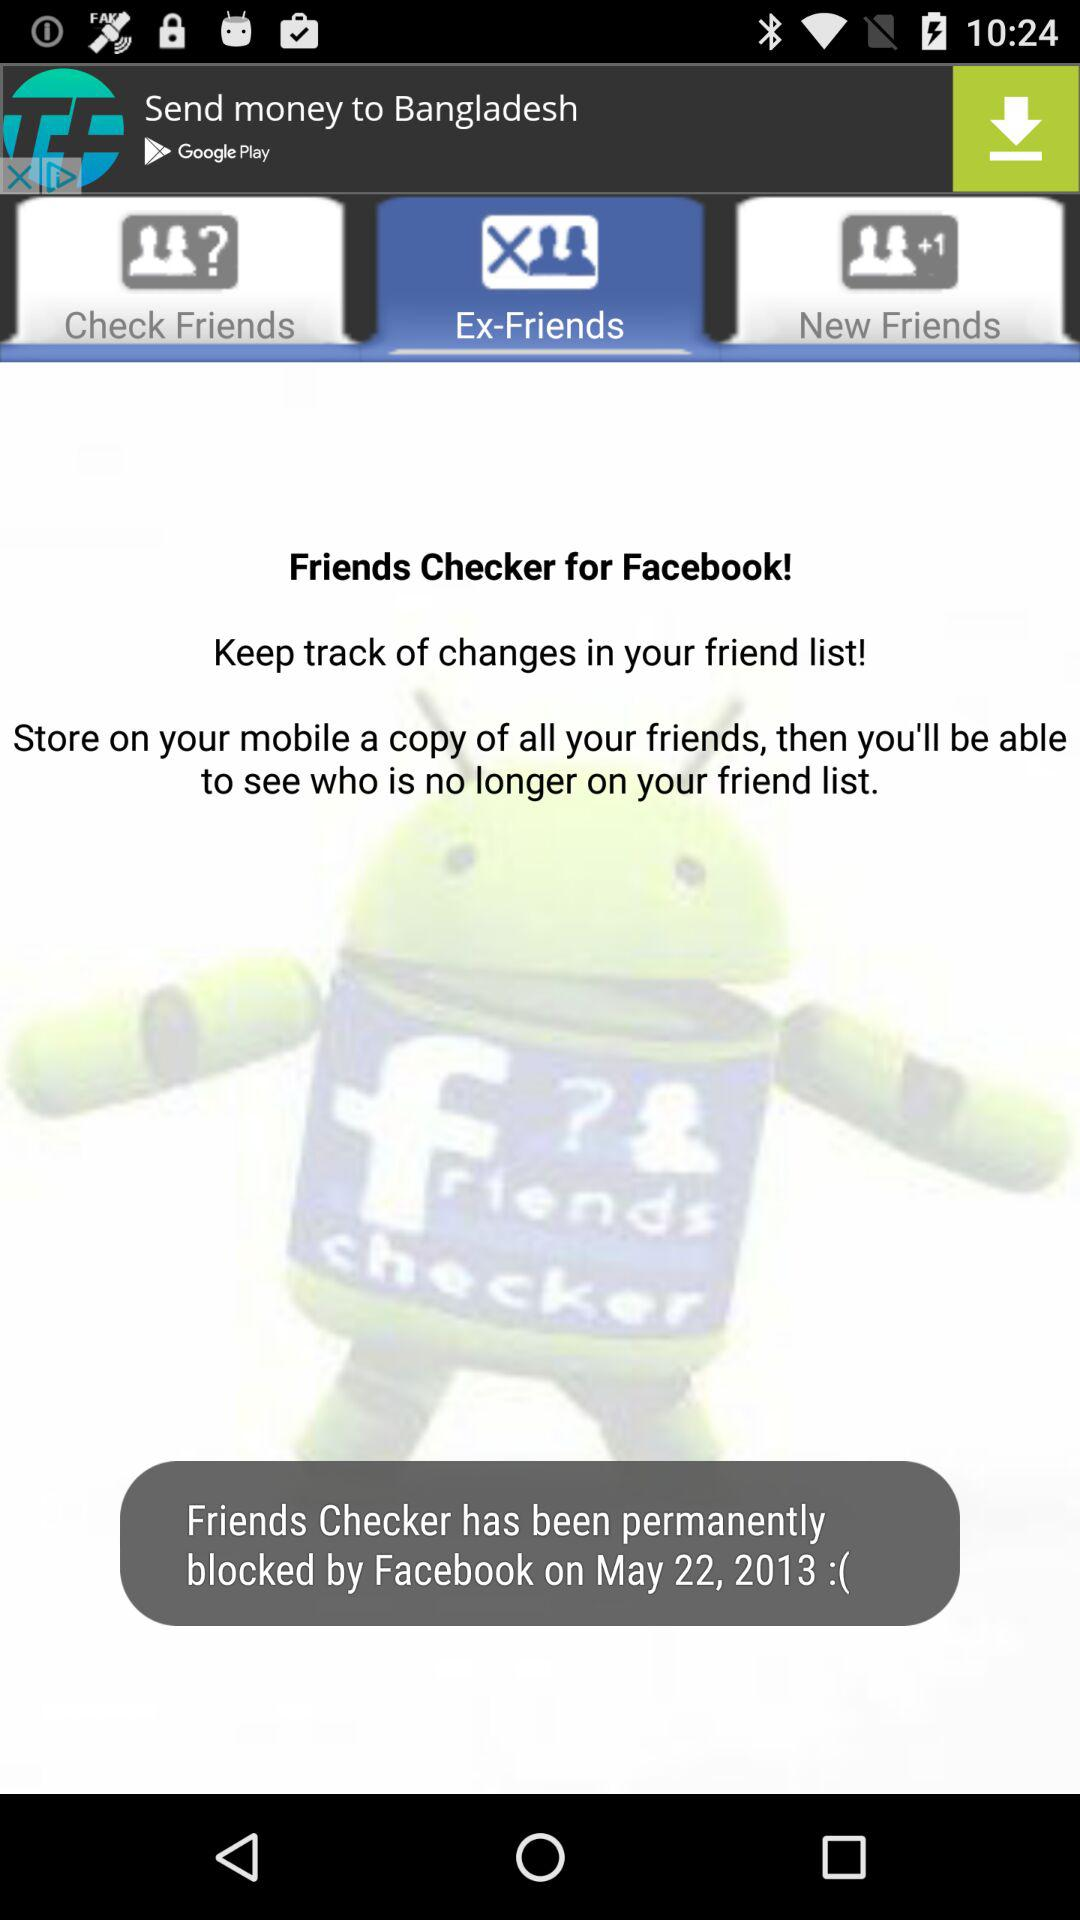What are the names of my friends?
When the provided information is insufficient, respond with <no answer>. <no answer> 